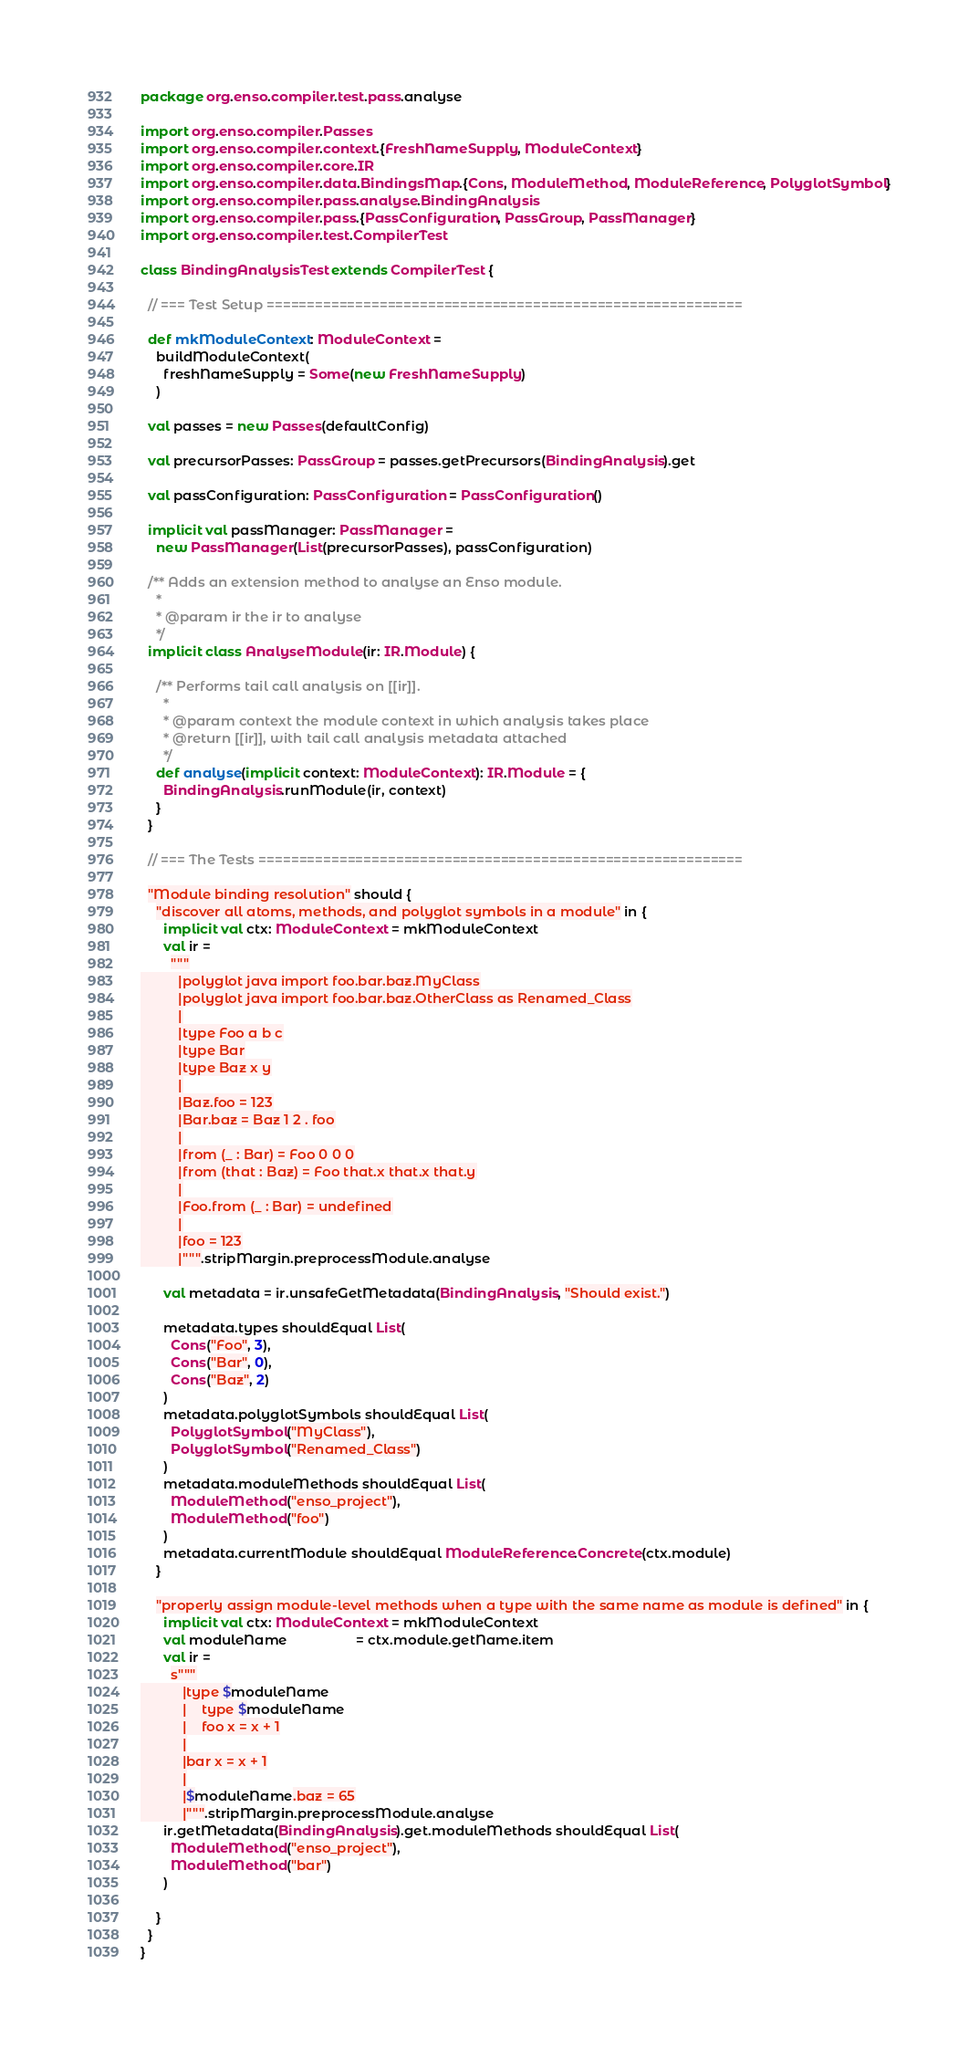<code> <loc_0><loc_0><loc_500><loc_500><_Scala_>package org.enso.compiler.test.pass.analyse

import org.enso.compiler.Passes
import org.enso.compiler.context.{FreshNameSupply, ModuleContext}
import org.enso.compiler.core.IR
import org.enso.compiler.data.BindingsMap.{Cons, ModuleMethod, ModuleReference, PolyglotSymbol}
import org.enso.compiler.pass.analyse.BindingAnalysis
import org.enso.compiler.pass.{PassConfiguration, PassGroup, PassManager}
import org.enso.compiler.test.CompilerTest

class BindingAnalysisTest extends CompilerTest {

  // === Test Setup ===========================================================

  def mkModuleContext: ModuleContext =
    buildModuleContext(
      freshNameSupply = Some(new FreshNameSupply)
    )

  val passes = new Passes(defaultConfig)

  val precursorPasses: PassGroup = passes.getPrecursors(BindingAnalysis).get

  val passConfiguration: PassConfiguration = PassConfiguration()

  implicit val passManager: PassManager =
    new PassManager(List(precursorPasses), passConfiguration)

  /** Adds an extension method to analyse an Enso module.
    *
    * @param ir the ir to analyse
    */
  implicit class AnalyseModule(ir: IR.Module) {

    /** Performs tail call analysis on [[ir]].
      *
      * @param context the module context in which analysis takes place
      * @return [[ir]], with tail call analysis metadata attached
      */
    def analyse(implicit context: ModuleContext): IR.Module = {
      BindingAnalysis.runModule(ir, context)
    }
  }

  // === The Tests ============================================================

  "Module binding resolution" should {
    "discover all atoms, methods, and polyglot symbols in a module" in {
      implicit val ctx: ModuleContext = mkModuleContext
      val ir =
        """
          |polyglot java import foo.bar.baz.MyClass
          |polyglot java import foo.bar.baz.OtherClass as Renamed_Class
          |
          |type Foo a b c
          |type Bar
          |type Baz x y
          |
          |Baz.foo = 123
          |Bar.baz = Baz 1 2 . foo
          |
          |from (_ : Bar) = Foo 0 0 0
          |from (that : Baz) = Foo that.x that.x that.y
          |
          |Foo.from (_ : Bar) = undefined
          |
          |foo = 123
          |""".stripMargin.preprocessModule.analyse

      val metadata = ir.unsafeGetMetadata(BindingAnalysis, "Should exist.")

      metadata.types shouldEqual List(
        Cons("Foo", 3),
        Cons("Bar", 0),
        Cons("Baz", 2)
      )
      metadata.polyglotSymbols shouldEqual List(
        PolyglotSymbol("MyClass"),
        PolyglotSymbol("Renamed_Class")
      )
      metadata.moduleMethods shouldEqual List(
        ModuleMethod("enso_project"),
        ModuleMethod("foo")
      )
      metadata.currentModule shouldEqual ModuleReference.Concrete(ctx.module)
    }

    "properly assign module-level methods when a type with the same name as module is defined" in {
      implicit val ctx: ModuleContext = mkModuleContext
      val moduleName                  = ctx.module.getName.item
      val ir =
        s"""
           |type $moduleName
           |    type $moduleName
           |    foo x = x + 1
           |
           |bar x = x + 1
           |
           |$moduleName.baz = 65
           |""".stripMargin.preprocessModule.analyse
      ir.getMetadata(BindingAnalysis).get.moduleMethods shouldEqual List(
        ModuleMethod("enso_project"),
        ModuleMethod("bar")
      )

    }
  }
}
</code> 